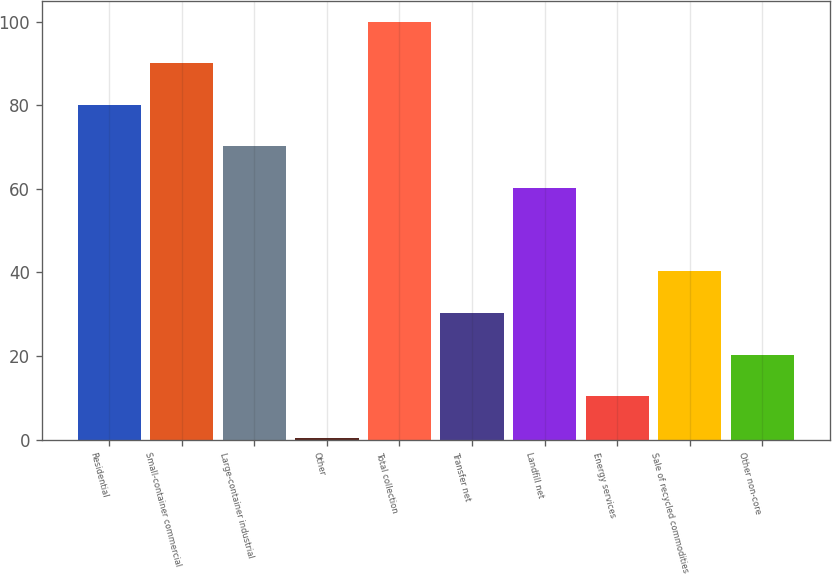Convert chart to OTSL. <chart><loc_0><loc_0><loc_500><loc_500><bar_chart><fcel>Residential<fcel>Small-container commercial<fcel>Large-container industrial<fcel>Other<fcel>Total collection<fcel>Transfer net<fcel>Landfill net<fcel>Energy services<fcel>Sale of recycled commodities<fcel>Other non-core<nl><fcel>80.08<fcel>90.04<fcel>70.12<fcel>0.4<fcel>100<fcel>30.28<fcel>60.16<fcel>10.36<fcel>40.24<fcel>20.32<nl></chart> 